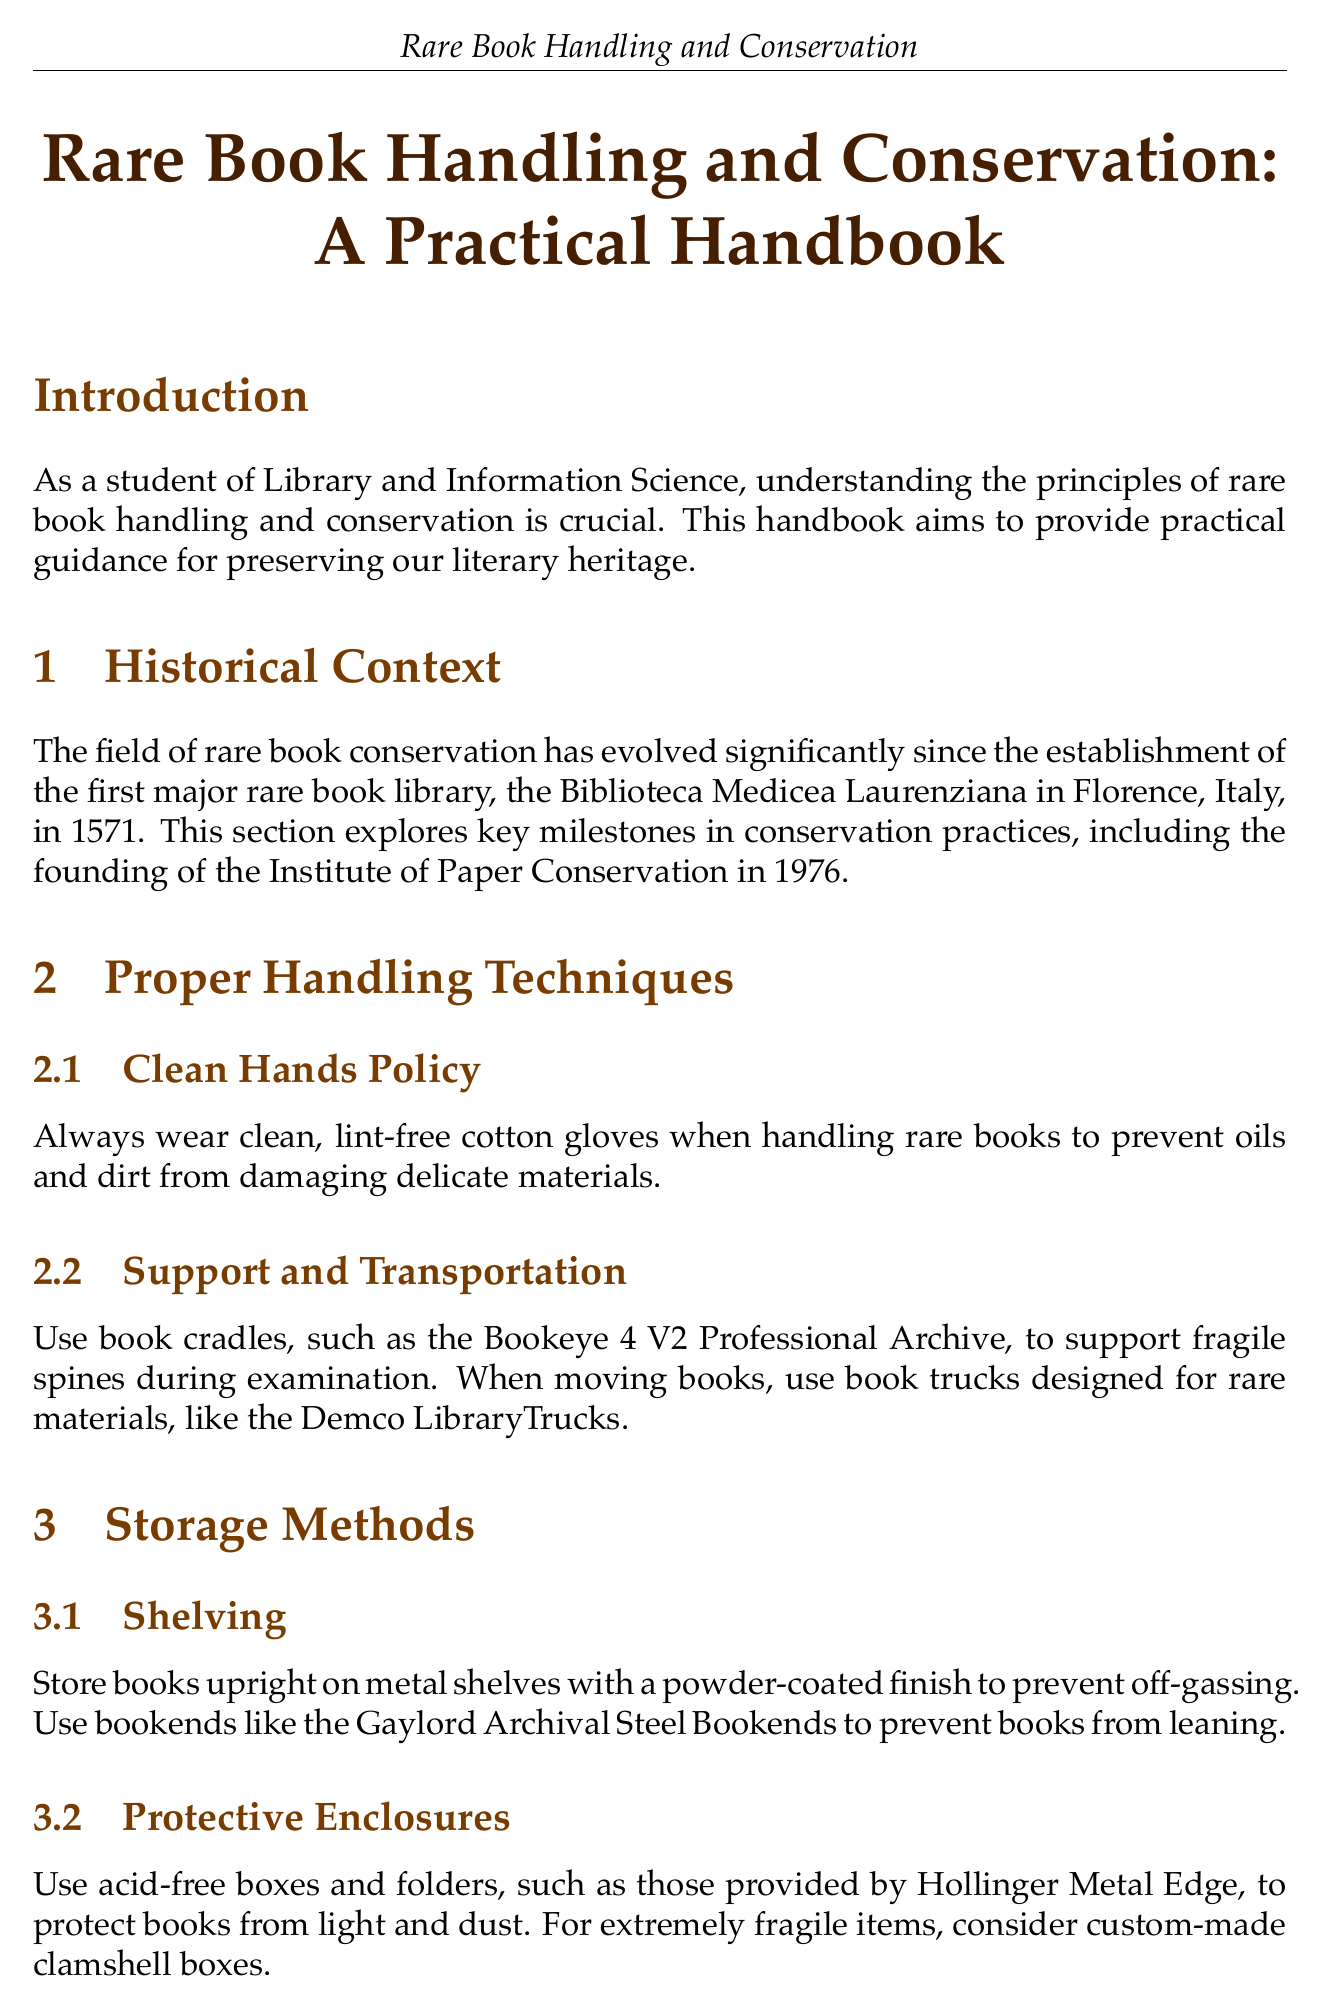What is the first major rare book library established? The document states the first major rare book library was the Biblioteca Medicea Laurenziana.
Answer: Biblioteca Medicea Laurenziana What year was the Institute of Paper Conservation founded? According to the document, the Institute of Paper Conservation was established in 1976.
Answer: 1976 What is the ideal temperature range for storing rare books? The document specifies a temperature range of 65-70°F for storing rare books.
Answer: 65-70°F What kind of gloves should be worn when handling rare books? It states that clean, lint-free cotton gloves should be used when handling rare books.
Answer: Clean, lint-free cotton gloves What materials are recommended for protective enclosures? The document suggests using acid-free boxes and folders for protective enclosures.
Answer: Acid-free boxes and folders Why should books be stored upright? The text explains that books should be stored upright to prevent them from leaning.
Answer: To prevent leaning What is a suitable device for monitoring environment conditions? The document mentions using dataloggers like the Onset HOBO MX1101 for monitoring conditions.
Answer: Onset HOBO MX1101 What should be used for minor repairs on rare books? It states that archival-quality materials like Filmoplast P90 should be used for minor repairs.
Answer: Filmoplast P90 What is the importance of digitization mentioned in the document? The document emphasizes that providing access to rare materials is equally important as preservation.
Answer: Providing access to rare materials 